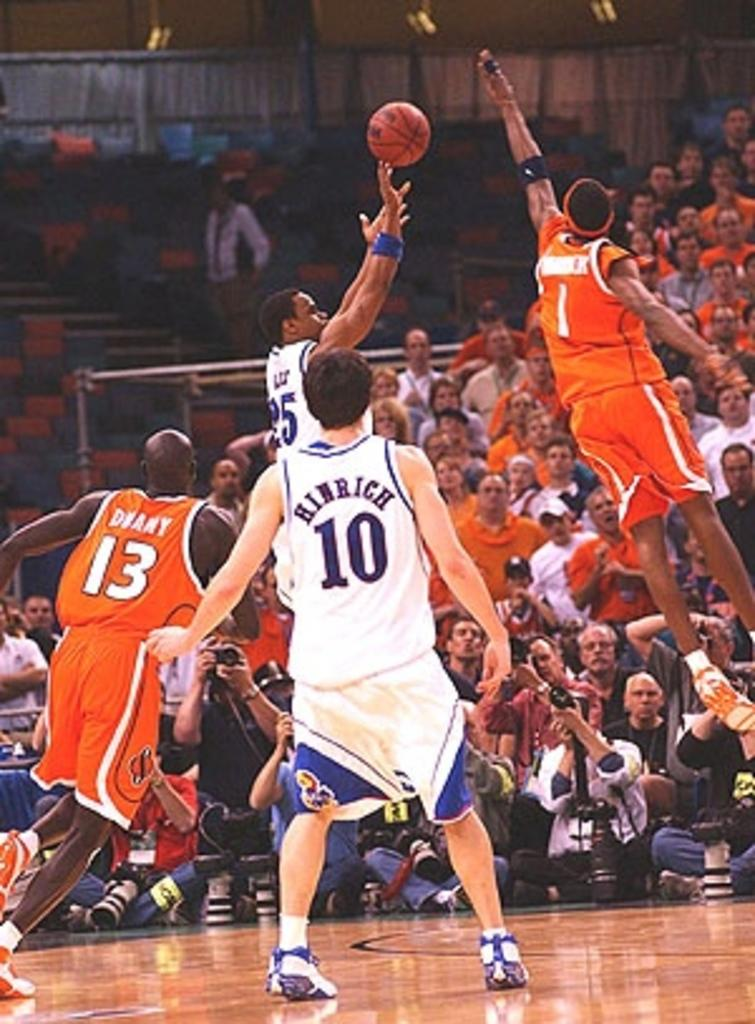What activity are the four members in the image engaged in? The four members are playing basketball in the image. Where is the basketball game taking place? The basketball game is taking place in the middle of the image. What can be seen in the background of the image? There is an audience and empty chairs in the background of the image. What type of toothbrush is being used by the players during the basketball game? There is no toothbrush present in the image, as the activity is basketball and not related to dental hygiene. 